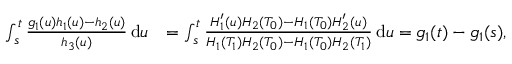Convert formula to latex. <formula><loc_0><loc_0><loc_500><loc_500>\begin{array} { r l } { \int _ { s } ^ { t } \frac { g _ { 1 } ( u ) h _ { 1 } ( u ) - h _ { 2 } ( u ) } { h _ { 3 } ( u ) } \, d u } & { = \int _ { s } ^ { t } \frac { H _ { 1 } ^ { \prime } ( u ) H _ { 2 } ( T _ { 0 } ) - H _ { 1 } ( T _ { 0 } ) H _ { 2 } ^ { \prime } ( u ) } { H _ { 1 } ( T _ { 1 } ) H _ { 2 } ( T _ { 0 } ) - H _ { 1 } ( T _ { 0 } ) H _ { 2 } ( T _ { 1 } ) } \, d u = g _ { 1 } ( t ) - g _ { 1 } ( s ) , } \end{array}</formula> 